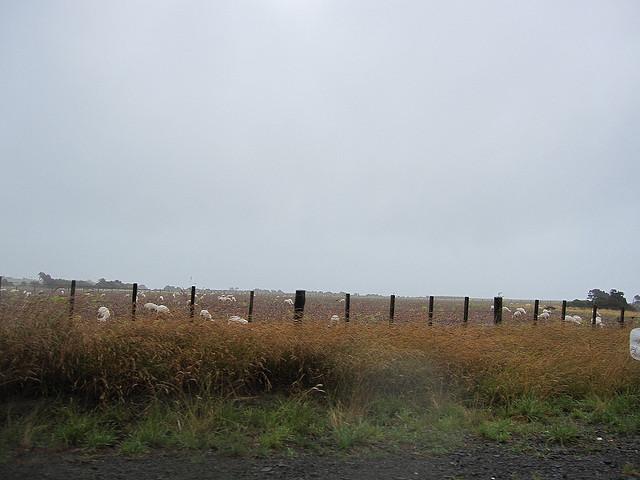Is this a bridge?
Write a very short answer. No. What are the sheep looking at?
Quick response, please. Grass. Any dogs pictured?
Concise answer only. No. Are there electric windmills?
Keep it brief. No. How many fence posts can you count?
Give a very brief answer. 14. Is the land totally flat?
Concise answer only. Yes. What type of fence is this?
Answer briefly. Wire. 